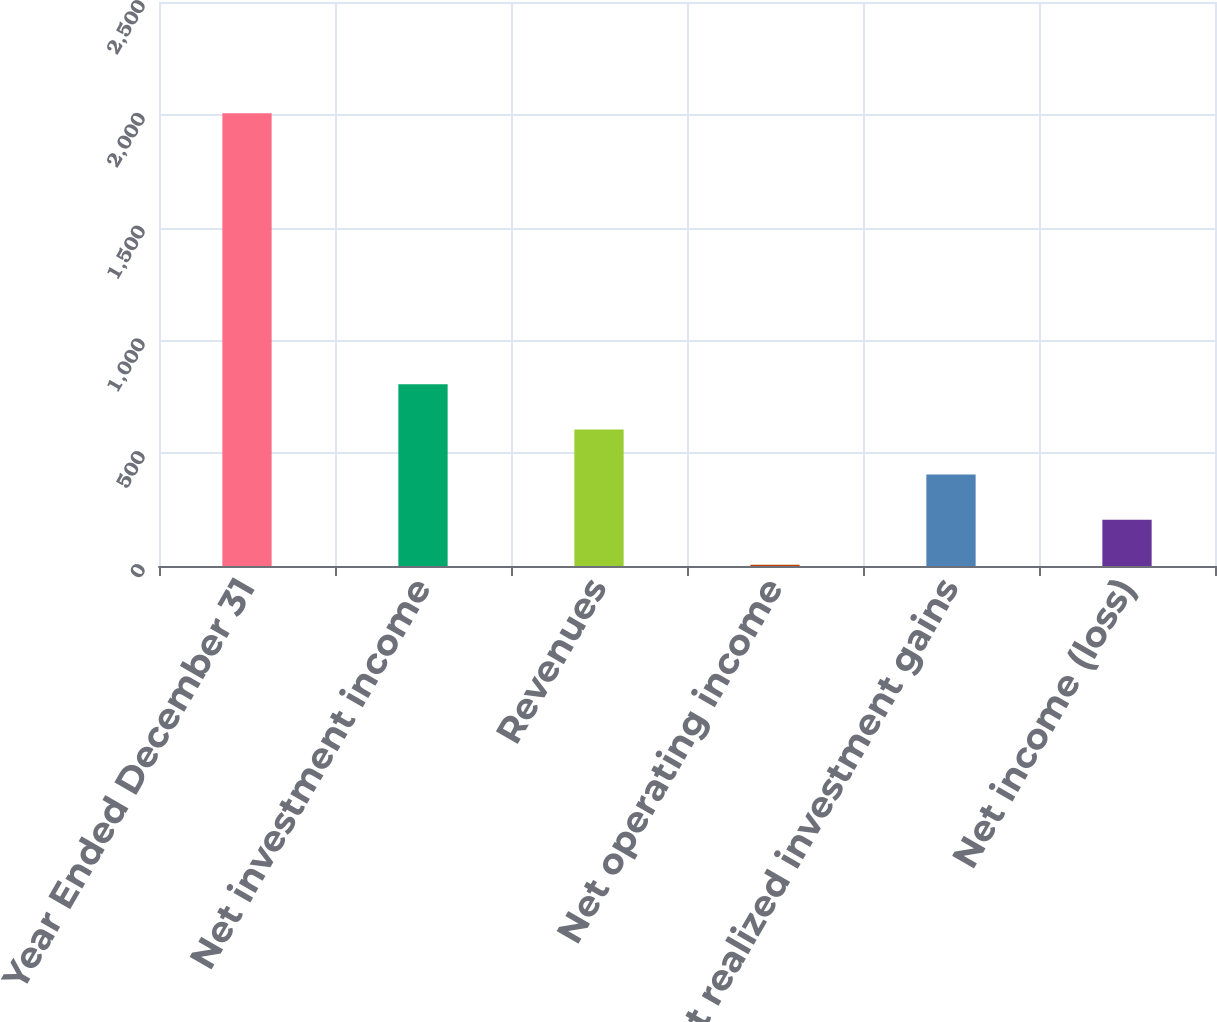<chart> <loc_0><loc_0><loc_500><loc_500><bar_chart><fcel>Year Ended December 31<fcel>Net investment income<fcel>Revenues<fcel>Net operating income<fcel>Net realized investment gains<fcel>Net income (loss)<nl><fcel>2007<fcel>805.8<fcel>605.6<fcel>5<fcel>405.4<fcel>205.2<nl></chart> 